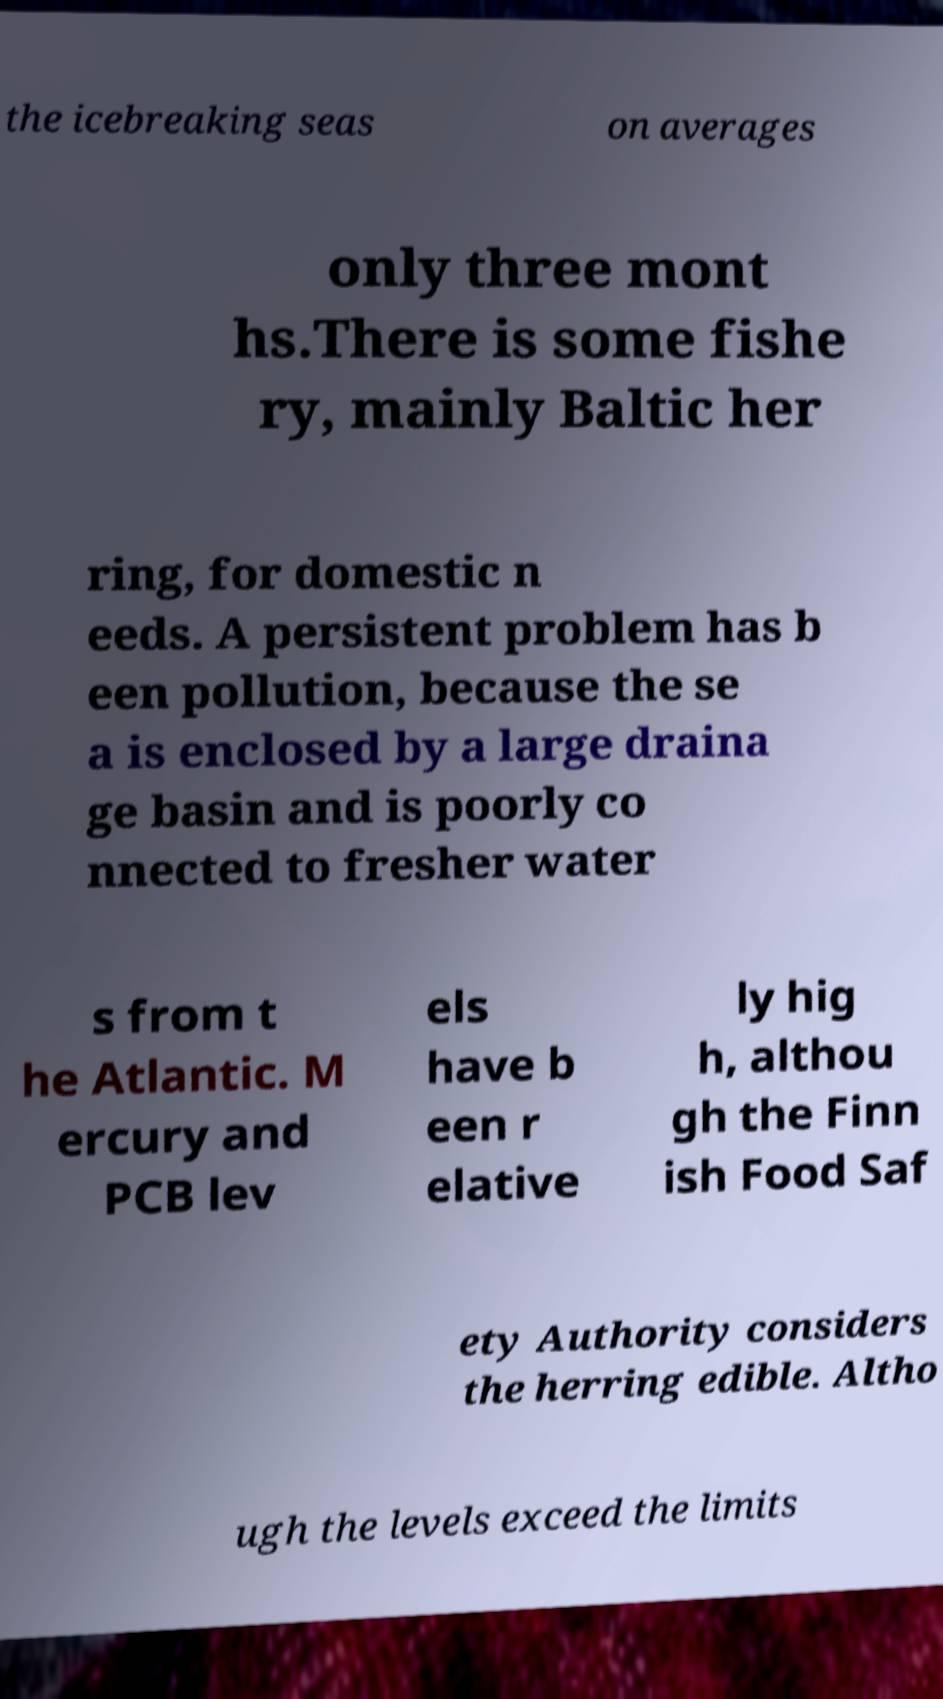I need the written content from this picture converted into text. Can you do that? the icebreaking seas on averages only three mont hs.There is some fishe ry, mainly Baltic her ring, for domestic n eeds. A persistent problem has b een pollution, because the se a is enclosed by a large draina ge basin and is poorly co nnected to fresher water s from t he Atlantic. M ercury and PCB lev els have b een r elative ly hig h, althou gh the Finn ish Food Saf ety Authority considers the herring edible. Altho ugh the levels exceed the limits 